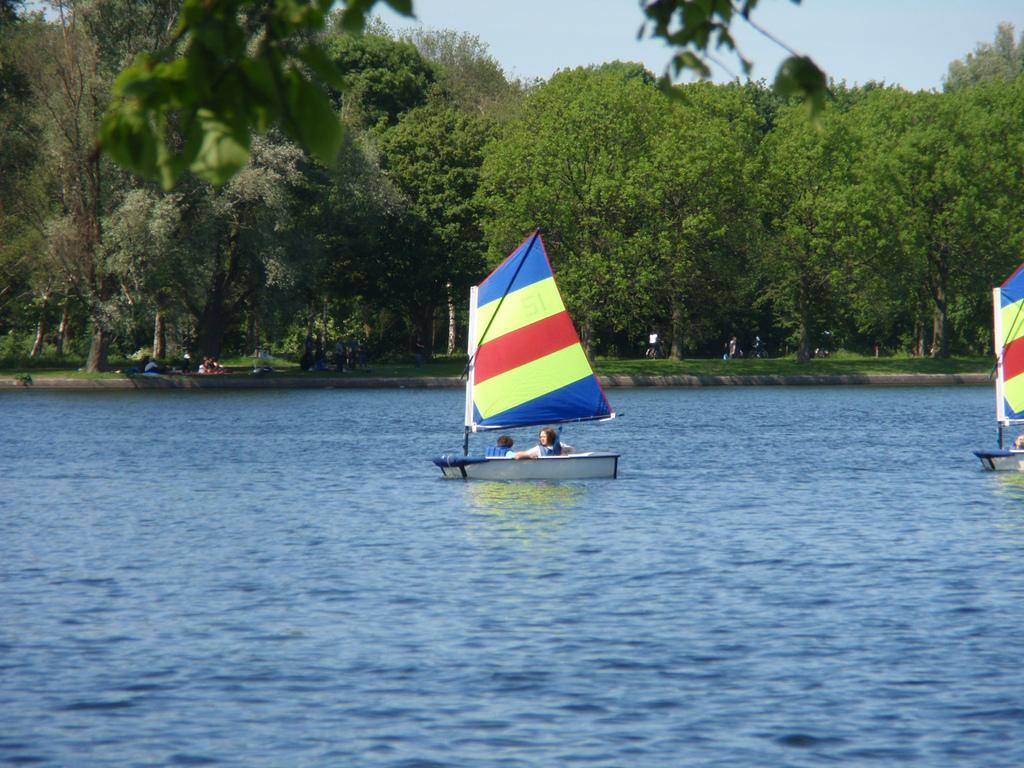What type of vehicles can be seen in the image? There are ships in the image. How many ships are there, and what are their colors? There are multiple ships in the image, and they are in different colors. What is the color of the water in the image? The water in the image is blue. What type of vegetation is present in the image? There are trees in the image. What is the color of the sky in the image? The sky in the image is blue. What type of cheese is being served for dinner in the image? There is no cheese or dinner present in the image; it features ships, water, trees, and a blue sky. Can you spot a rabbit hiding among the trees in the image? There is no rabbit present in the image; it only features ships, water, trees, and a blue sky. 